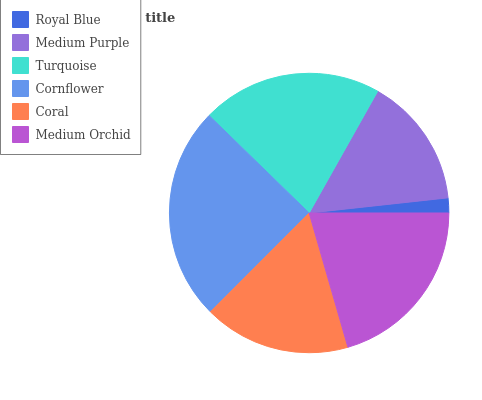Is Royal Blue the minimum?
Answer yes or no. Yes. Is Cornflower the maximum?
Answer yes or no. Yes. Is Medium Purple the minimum?
Answer yes or no. No. Is Medium Purple the maximum?
Answer yes or no. No. Is Medium Purple greater than Royal Blue?
Answer yes or no. Yes. Is Royal Blue less than Medium Purple?
Answer yes or no. Yes. Is Royal Blue greater than Medium Purple?
Answer yes or no. No. Is Medium Purple less than Royal Blue?
Answer yes or no. No. Is Medium Orchid the high median?
Answer yes or no. Yes. Is Coral the low median?
Answer yes or no. Yes. Is Royal Blue the high median?
Answer yes or no. No. Is Cornflower the low median?
Answer yes or no. No. 